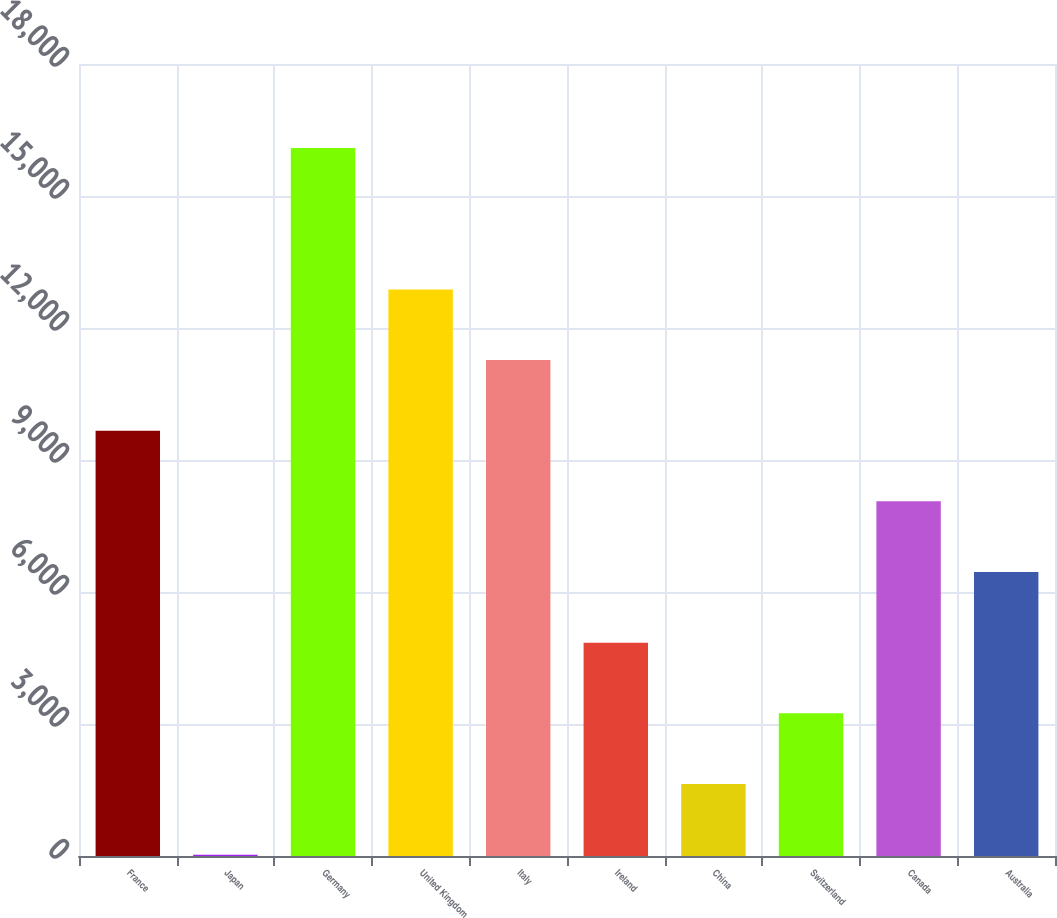Convert chart. <chart><loc_0><loc_0><loc_500><loc_500><bar_chart><fcel>France<fcel>Japan<fcel>Germany<fcel>United Kingdom<fcel>Italy<fcel>Ireland<fcel>China<fcel>Switzerland<fcel>Canada<fcel>Australia<nl><fcel>9665.8<fcel>31<fcel>16089<fcel>12877.4<fcel>11271.6<fcel>4848.4<fcel>1636.8<fcel>3242.6<fcel>8060<fcel>6454.2<nl></chart> 